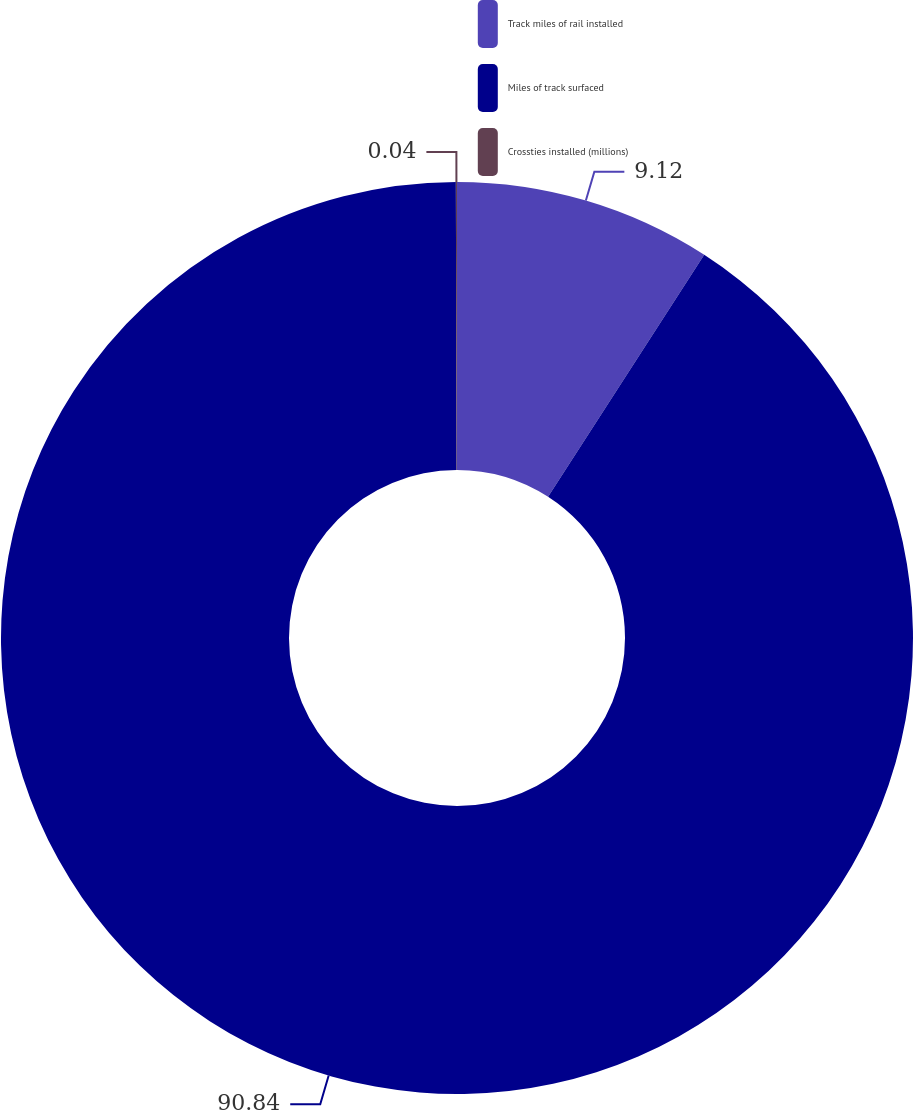<chart> <loc_0><loc_0><loc_500><loc_500><pie_chart><fcel>Track miles of rail installed<fcel>Miles of track surfaced<fcel>Crossties installed (millions)<nl><fcel>9.12%<fcel>90.84%<fcel>0.04%<nl></chart> 